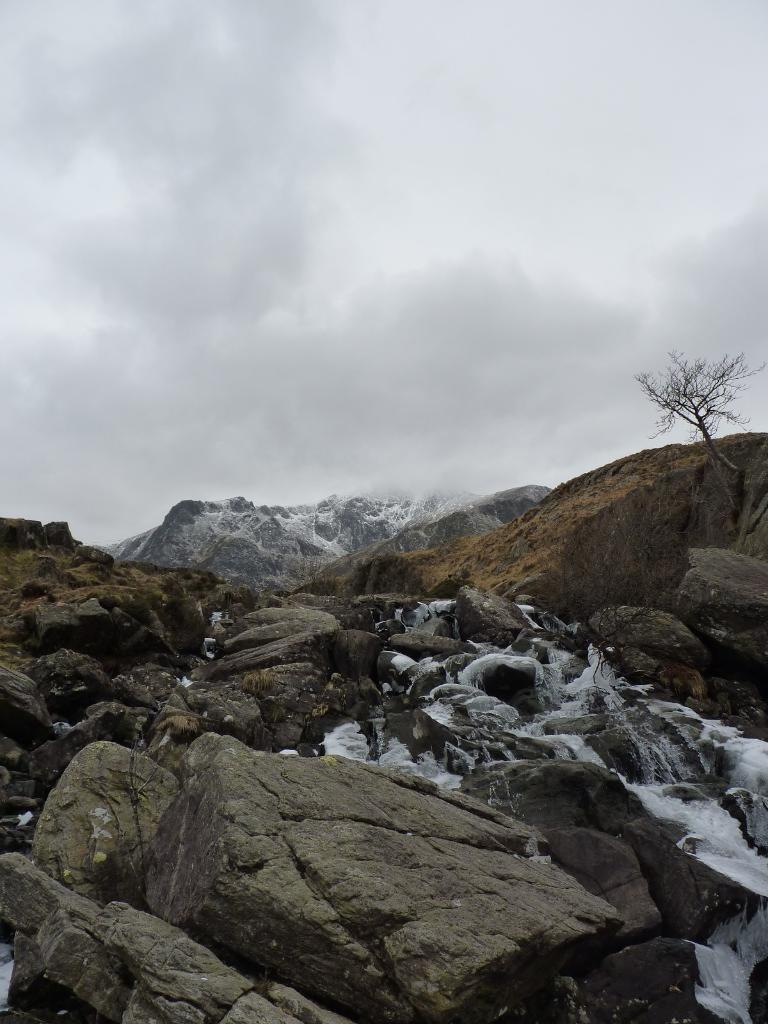What type of natural elements can be seen at the bottom of the image? There are rocks at the bottom side of the image. What can be found on the right side of the image? There is a dried plant on the right side of the image. What is visible at the top side of the image? The sky is visible at the top side of the image. Is there anyone driving a car in the image? There is no car or person driving in the image. How many snakes are visible in the image? There are no snakes present in the image. 